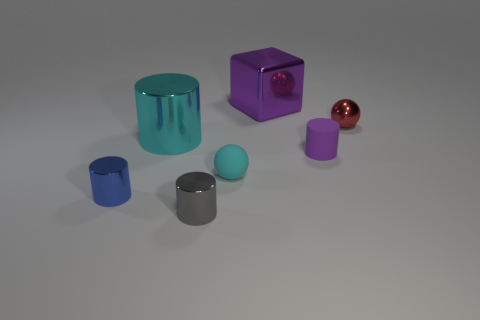Subtract 1 cylinders. How many cylinders are left? 3 Add 2 shiny blocks. How many objects exist? 9 Subtract all cylinders. How many objects are left? 3 Subtract 0 brown cylinders. How many objects are left? 7 Subtract all big cyan things. Subtract all cyan rubber cylinders. How many objects are left? 6 Add 4 small purple matte cylinders. How many small purple matte cylinders are left? 5 Add 3 cyan cylinders. How many cyan cylinders exist? 4 